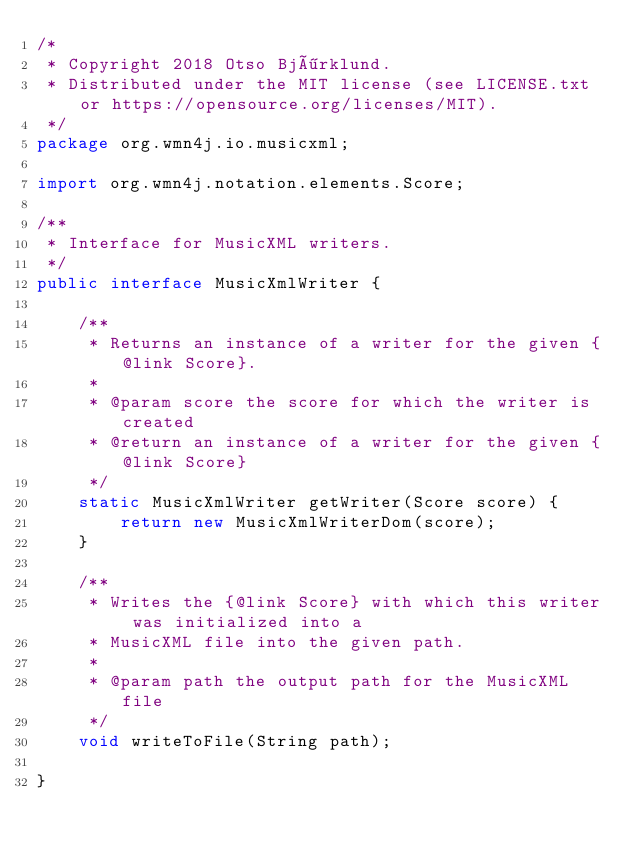Convert code to text. <code><loc_0><loc_0><loc_500><loc_500><_Java_>/*
 * Copyright 2018 Otso Björklund.
 * Distributed under the MIT license (see LICENSE.txt or https://opensource.org/licenses/MIT).
 */
package org.wmn4j.io.musicxml;

import org.wmn4j.notation.elements.Score;

/**
 * Interface for MusicXML writers.
 */
public interface MusicXmlWriter {

	/**
	 * Returns an instance of a writer for the given {@link Score}.
	 *
	 * @param score the score for which the writer is created
	 * @return an instance of a writer for the given {@link Score}
	 */
	static MusicXmlWriter getWriter(Score score) {
		return new MusicXmlWriterDom(score);
	}

	/**
	 * Writes the {@link Score} with which this writer was initialized into a
	 * MusicXML file into the given path.
	 *
	 * @param path the output path for the MusicXML file
	 */
	void writeToFile(String path);

}
</code> 